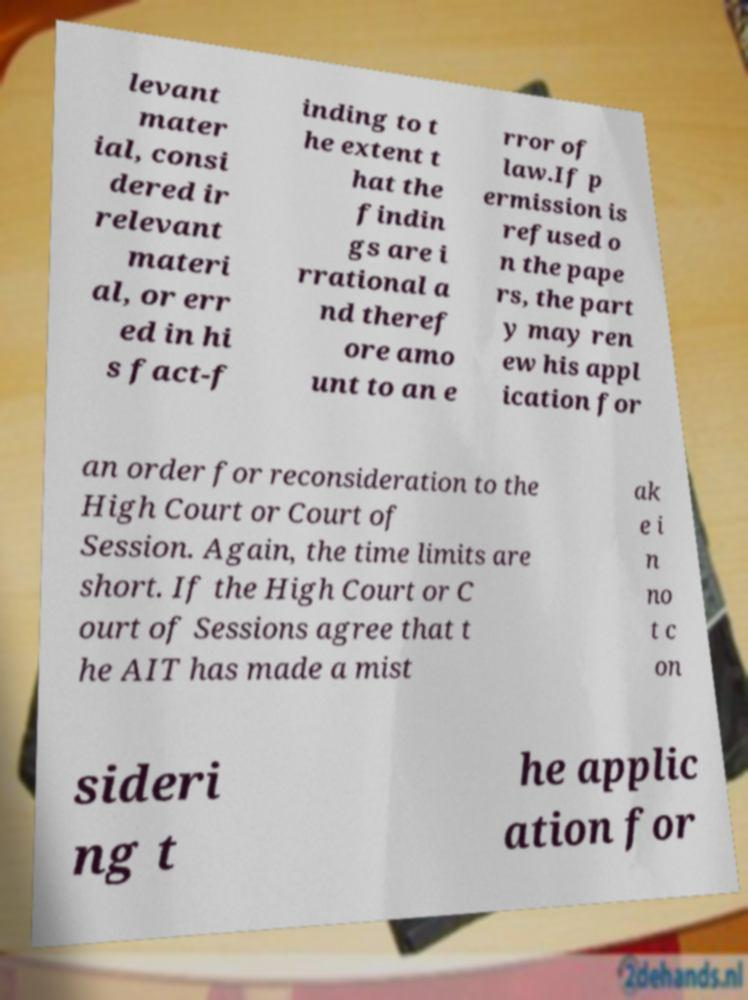Can you accurately transcribe the text from the provided image for me? levant mater ial, consi dered ir relevant materi al, or err ed in hi s fact-f inding to t he extent t hat the findin gs are i rrational a nd theref ore amo unt to an e rror of law.If p ermission is refused o n the pape rs, the part y may ren ew his appl ication for an order for reconsideration to the High Court or Court of Session. Again, the time limits are short. If the High Court or C ourt of Sessions agree that t he AIT has made a mist ak e i n no t c on sideri ng t he applic ation for 